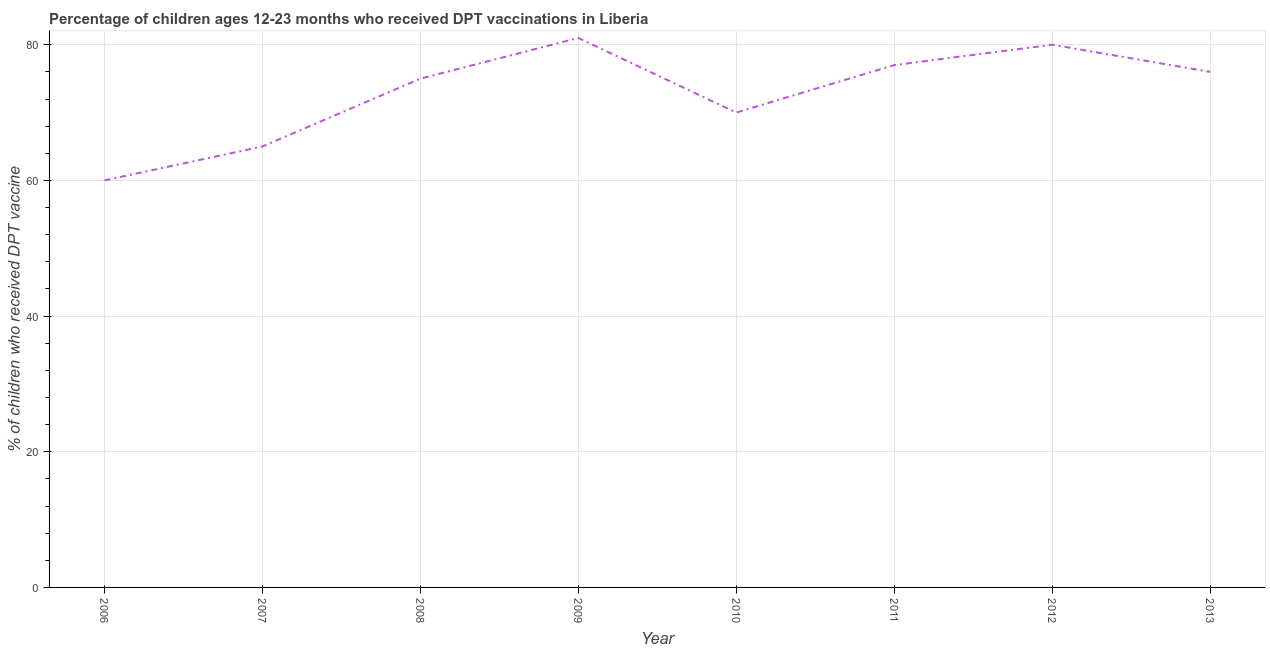What is the percentage of children who received dpt vaccine in 2010?
Give a very brief answer. 70. Across all years, what is the maximum percentage of children who received dpt vaccine?
Your answer should be very brief. 81. Across all years, what is the minimum percentage of children who received dpt vaccine?
Provide a succinct answer. 60. In which year was the percentage of children who received dpt vaccine maximum?
Offer a terse response. 2009. In which year was the percentage of children who received dpt vaccine minimum?
Give a very brief answer. 2006. What is the sum of the percentage of children who received dpt vaccine?
Your answer should be compact. 584. What is the difference between the percentage of children who received dpt vaccine in 2010 and 2013?
Your response must be concise. -6. What is the median percentage of children who received dpt vaccine?
Your answer should be very brief. 75.5. What is the ratio of the percentage of children who received dpt vaccine in 2006 to that in 2008?
Offer a terse response. 0.8. What is the difference between the highest and the second highest percentage of children who received dpt vaccine?
Offer a terse response. 1. What is the difference between the highest and the lowest percentage of children who received dpt vaccine?
Keep it short and to the point. 21. In how many years, is the percentage of children who received dpt vaccine greater than the average percentage of children who received dpt vaccine taken over all years?
Offer a terse response. 5. How many years are there in the graph?
Keep it short and to the point. 8. Does the graph contain any zero values?
Give a very brief answer. No. Does the graph contain grids?
Your answer should be compact. Yes. What is the title of the graph?
Provide a succinct answer. Percentage of children ages 12-23 months who received DPT vaccinations in Liberia. What is the label or title of the X-axis?
Provide a succinct answer. Year. What is the label or title of the Y-axis?
Your answer should be compact. % of children who received DPT vaccine. What is the % of children who received DPT vaccine of 2008?
Your answer should be very brief. 75. What is the % of children who received DPT vaccine of 2012?
Make the answer very short. 80. What is the difference between the % of children who received DPT vaccine in 2006 and 2011?
Keep it short and to the point. -17. What is the difference between the % of children who received DPT vaccine in 2006 and 2012?
Your response must be concise. -20. What is the difference between the % of children who received DPT vaccine in 2006 and 2013?
Your response must be concise. -16. What is the difference between the % of children who received DPT vaccine in 2007 and 2012?
Ensure brevity in your answer.  -15. What is the difference between the % of children who received DPT vaccine in 2008 and 2013?
Offer a very short reply. -1. What is the difference between the % of children who received DPT vaccine in 2009 and 2011?
Provide a succinct answer. 4. What is the difference between the % of children who received DPT vaccine in 2009 and 2013?
Ensure brevity in your answer.  5. What is the difference between the % of children who received DPT vaccine in 2010 and 2011?
Your answer should be very brief. -7. What is the difference between the % of children who received DPT vaccine in 2010 and 2012?
Your answer should be compact. -10. What is the difference between the % of children who received DPT vaccine in 2010 and 2013?
Your answer should be very brief. -6. What is the difference between the % of children who received DPT vaccine in 2011 and 2013?
Provide a succinct answer. 1. What is the difference between the % of children who received DPT vaccine in 2012 and 2013?
Your response must be concise. 4. What is the ratio of the % of children who received DPT vaccine in 2006 to that in 2007?
Give a very brief answer. 0.92. What is the ratio of the % of children who received DPT vaccine in 2006 to that in 2009?
Provide a short and direct response. 0.74. What is the ratio of the % of children who received DPT vaccine in 2006 to that in 2010?
Your answer should be very brief. 0.86. What is the ratio of the % of children who received DPT vaccine in 2006 to that in 2011?
Provide a short and direct response. 0.78. What is the ratio of the % of children who received DPT vaccine in 2006 to that in 2013?
Your response must be concise. 0.79. What is the ratio of the % of children who received DPT vaccine in 2007 to that in 2008?
Your answer should be compact. 0.87. What is the ratio of the % of children who received DPT vaccine in 2007 to that in 2009?
Your response must be concise. 0.8. What is the ratio of the % of children who received DPT vaccine in 2007 to that in 2010?
Offer a very short reply. 0.93. What is the ratio of the % of children who received DPT vaccine in 2007 to that in 2011?
Your response must be concise. 0.84. What is the ratio of the % of children who received DPT vaccine in 2007 to that in 2012?
Provide a short and direct response. 0.81. What is the ratio of the % of children who received DPT vaccine in 2007 to that in 2013?
Your response must be concise. 0.85. What is the ratio of the % of children who received DPT vaccine in 2008 to that in 2009?
Offer a terse response. 0.93. What is the ratio of the % of children who received DPT vaccine in 2008 to that in 2010?
Give a very brief answer. 1.07. What is the ratio of the % of children who received DPT vaccine in 2008 to that in 2011?
Provide a succinct answer. 0.97. What is the ratio of the % of children who received DPT vaccine in 2008 to that in 2012?
Make the answer very short. 0.94. What is the ratio of the % of children who received DPT vaccine in 2009 to that in 2010?
Give a very brief answer. 1.16. What is the ratio of the % of children who received DPT vaccine in 2009 to that in 2011?
Offer a terse response. 1.05. What is the ratio of the % of children who received DPT vaccine in 2009 to that in 2012?
Offer a terse response. 1.01. What is the ratio of the % of children who received DPT vaccine in 2009 to that in 2013?
Your answer should be compact. 1.07. What is the ratio of the % of children who received DPT vaccine in 2010 to that in 2011?
Your answer should be very brief. 0.91. What is the ratio of the % of children who received DPT vaccine in 2010 to that in 2012?
Give a very brief answer. 0.88. What is the ratio of the % of children who received DPT vaccine in 2010 to that in 2013?
Ensure brevity in your answer.  0.92. What is the ratio of the % of children who received DPT vaccine in 2011 to that in 2012?
Your answer should be very brief. 0.96. What is the ratio of the % of children who received DPT vaccine in 2011 to that in 2013?
Your response must be concise. 1.01. What is the ratio of the % of children who received DPT vaccine in 2012 to that in 2013?
Offer a very short reply. 1.05. 